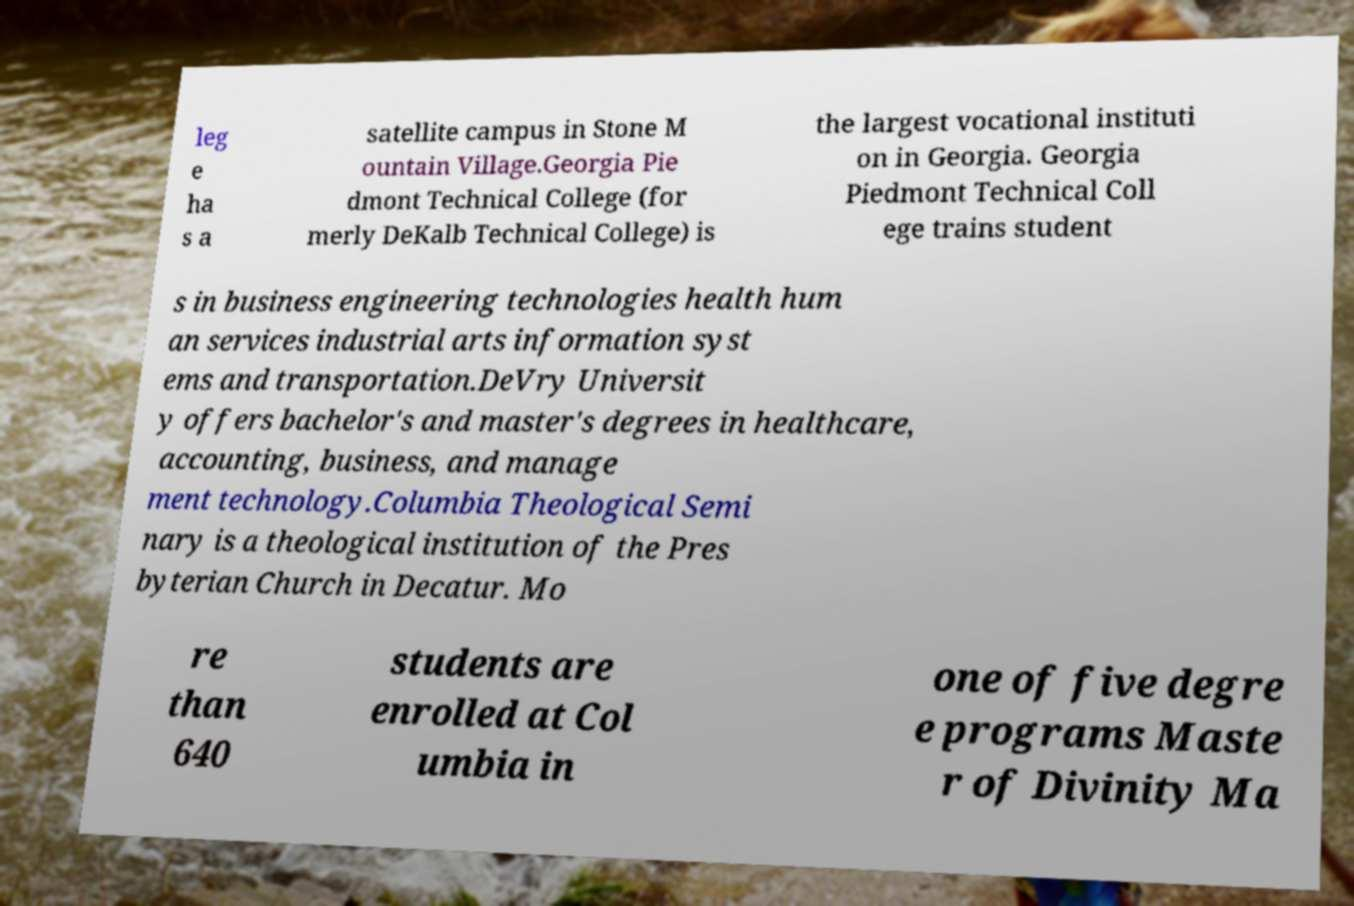For documentation purposes, I need the text within this image transcribed. Could you provide that? leg e ha s a satellite campus in Stone M ountain Village.Georgia Pie dmont Technical College (for merly DeKalb Technical College) is the largest vocational instituti on in Georgia. Georgia Piedmont Technical Coll ege trains student s in business engineering technologies health hum an services industrial arts information syst ems and transportation.DeVry Universit y offers bachelor's and master's degrees in healthcare, accounting, business, and manage ment technology.Columbia Theological Semi nary is a theological institution of the Pres byterian Church in Decatur. Mo re than 640 students are enrolled at Col umbia in one of five degre e programs Maste r of Divinity Ma 